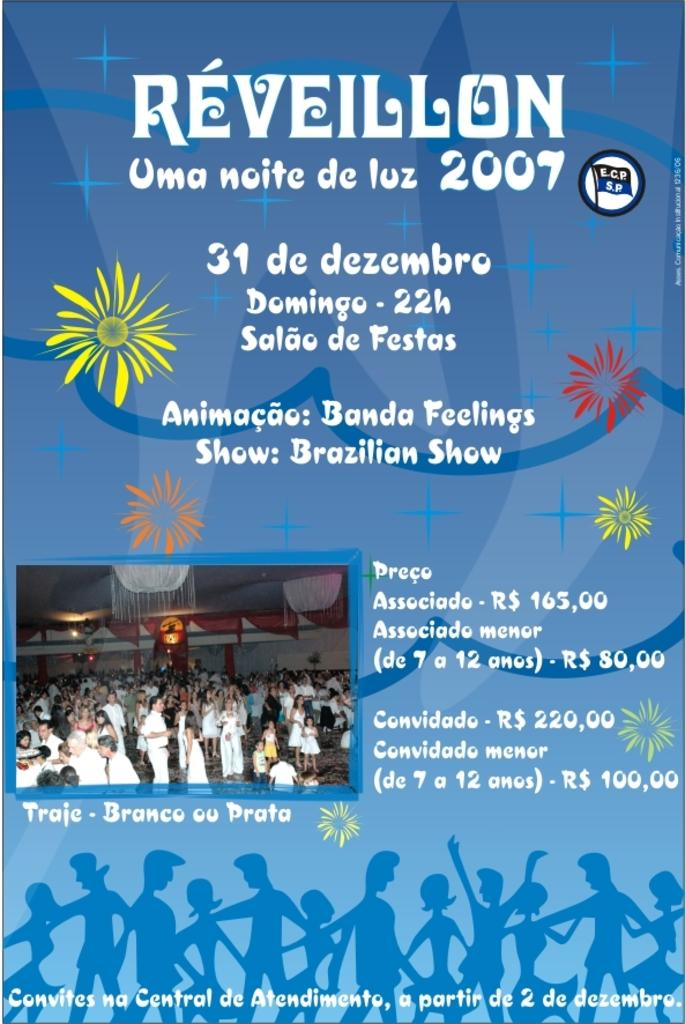<image>
Provide a brief description of the given image. Reveillon is a concert offered in Brazil during December. 